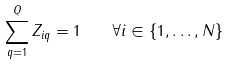<formula> <loc_0><loc_0><loc_500><loc_500>\sum _ { q = 1 } ^ { Q } Z _ { i q } = 1 \quad \forall i \in \{ 1 , \dots , N \}</formula> 